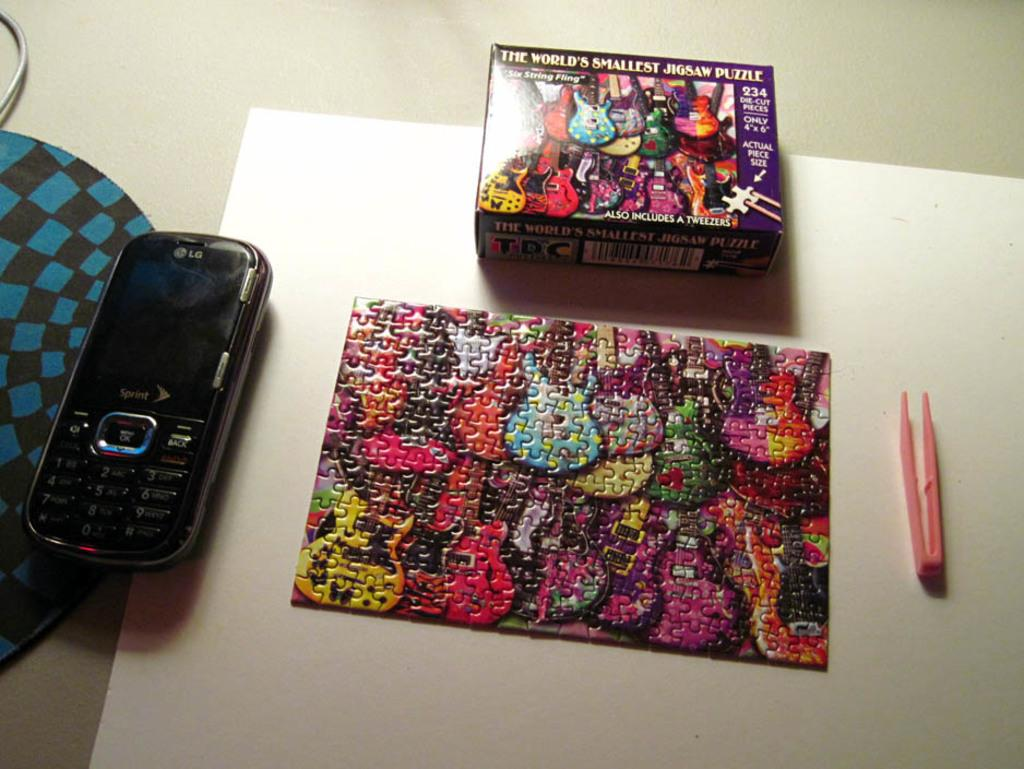<image>
Give a short and clear explanation of the subsequent image. The World's Smallest Jigsaw Puzzle is completed on a table. 